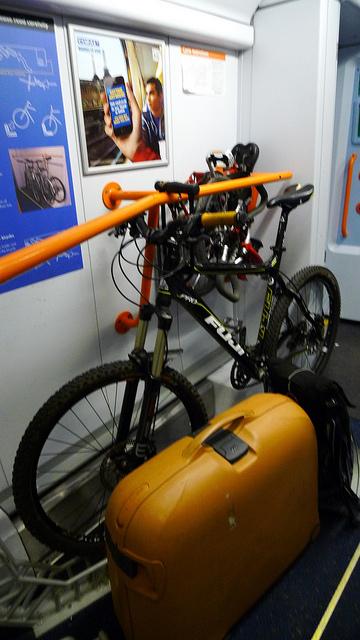What mode of transport is pictured?
Concise answer only. Bicycle. What color is the wall?
Be succinct. White. What color is the railing?
Be succinct. Orange. 